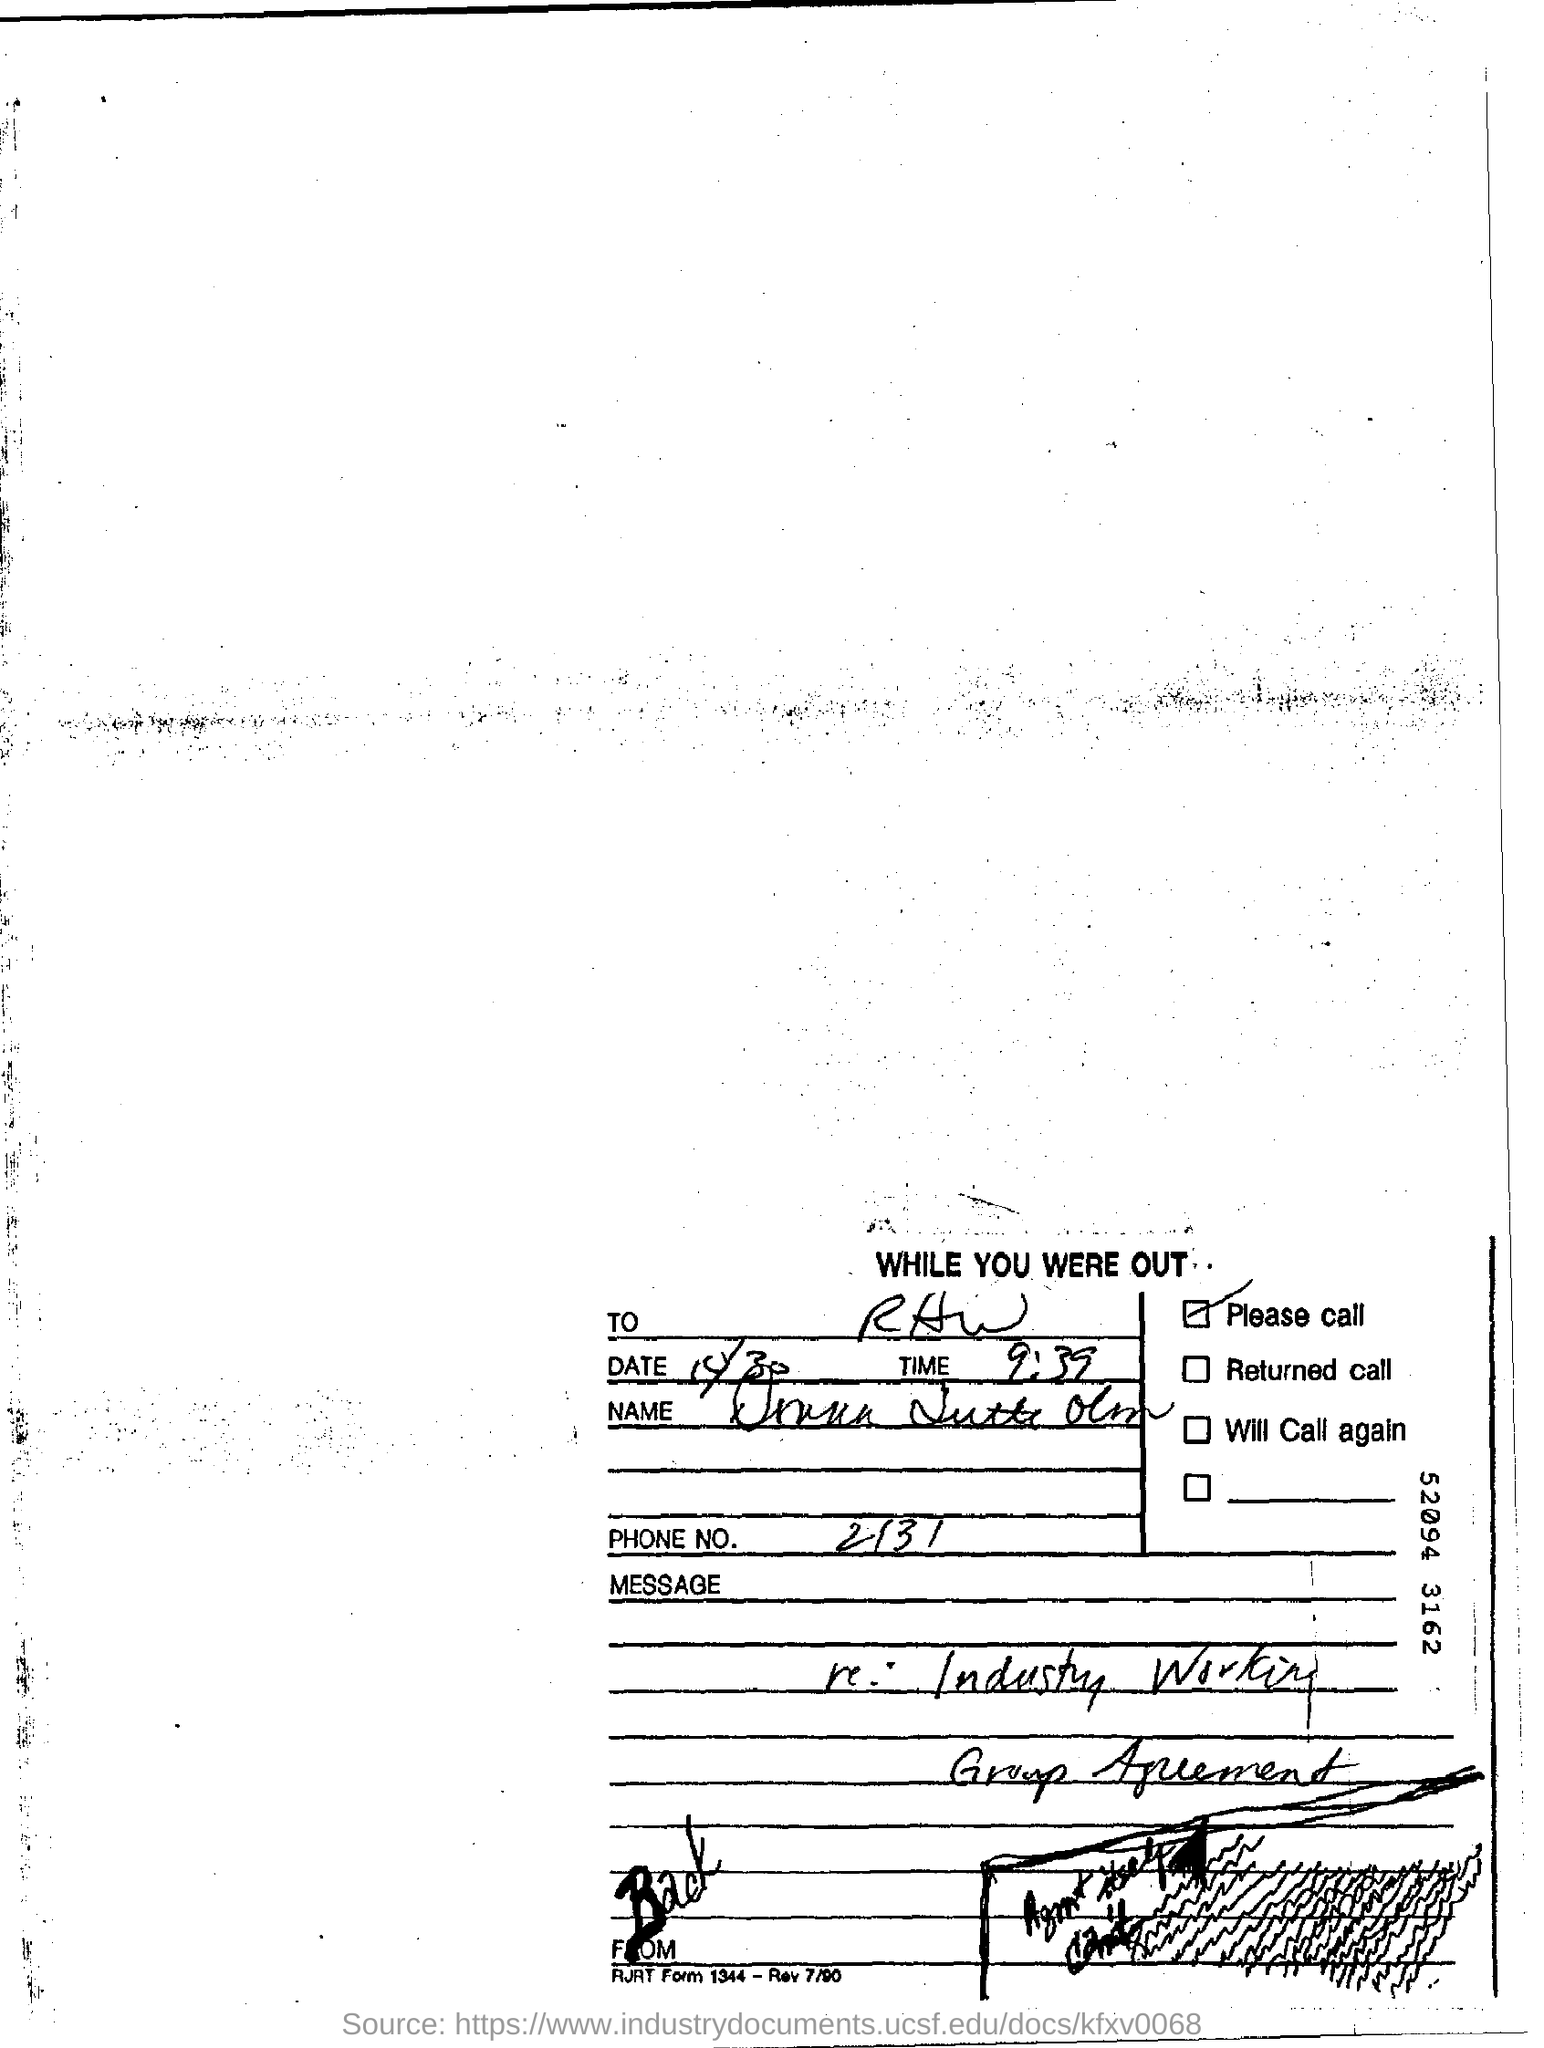What is the Time?
Your answer should be compact. 9:39. What is the Phone No.?
Your answer should be very brief. 2131. 